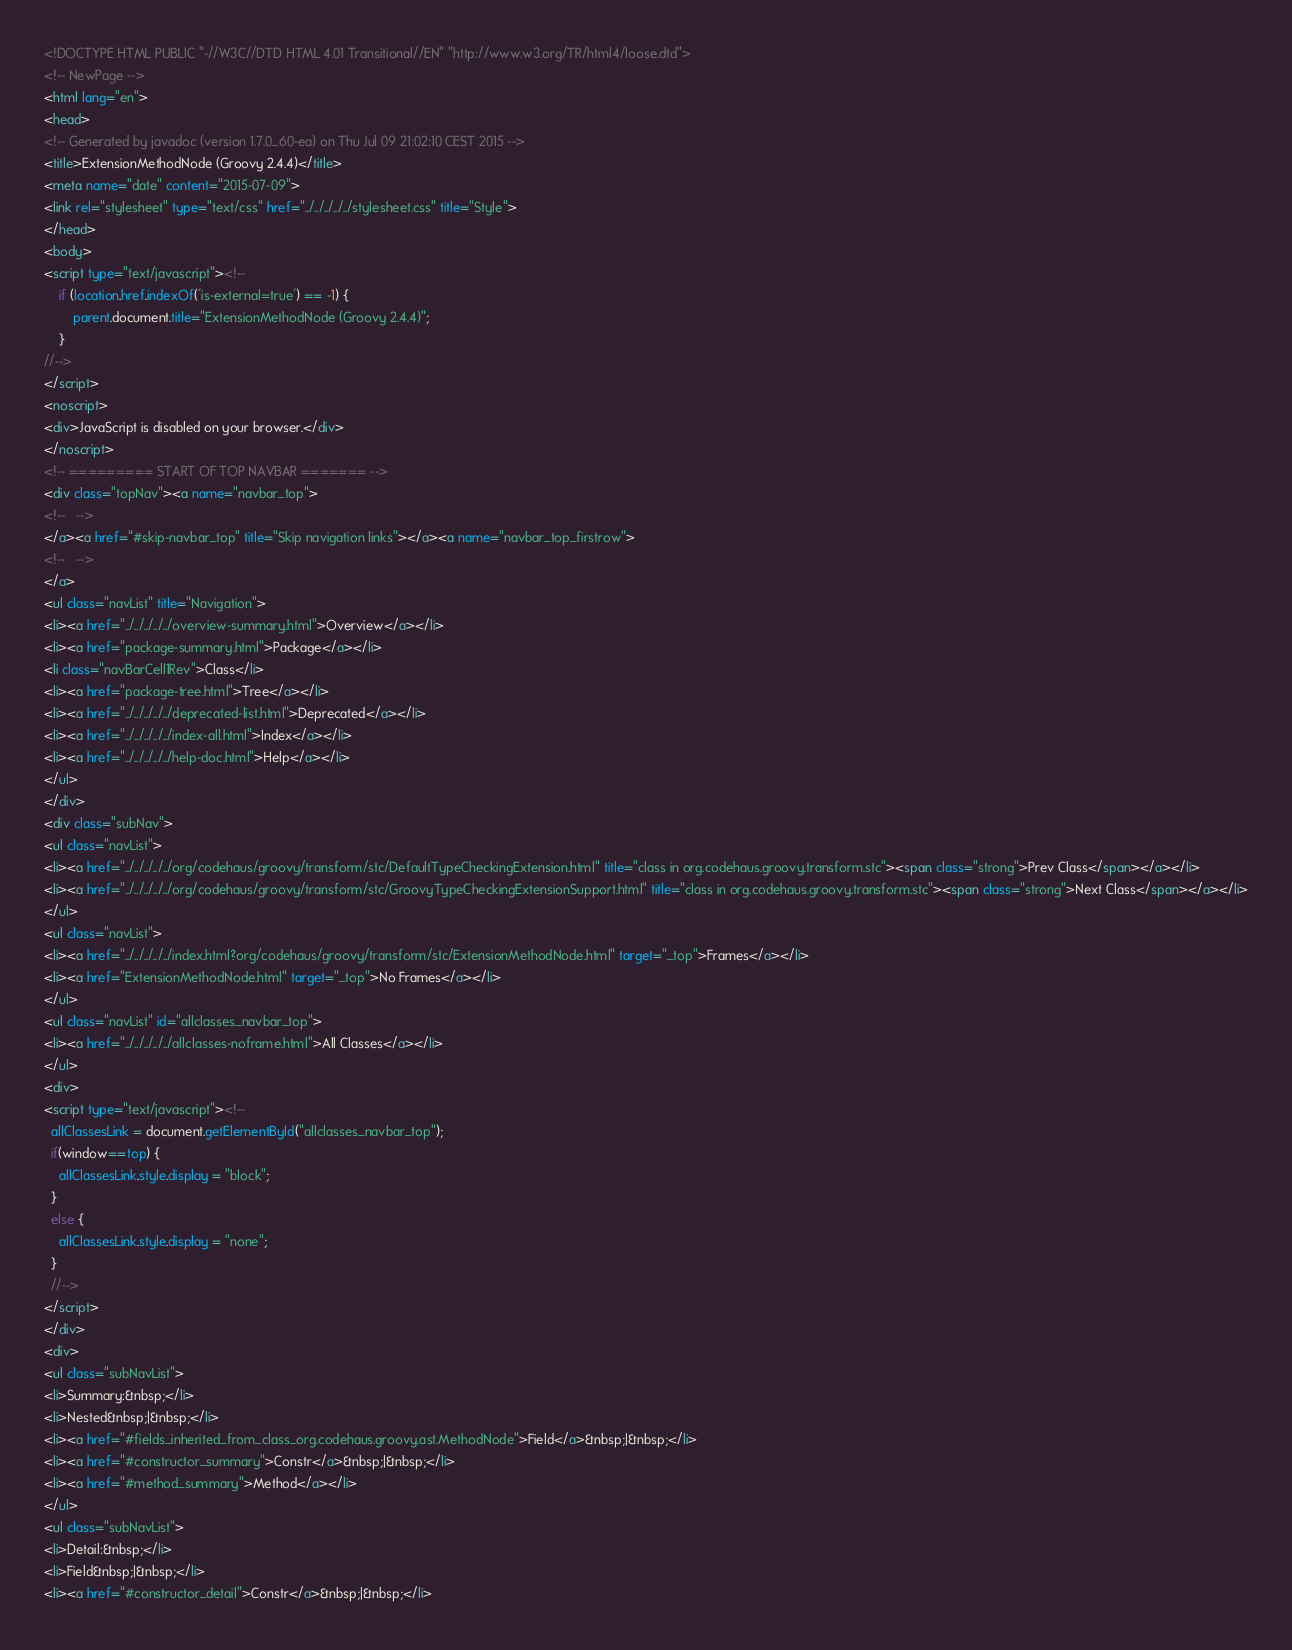<code> <loc_0><loc_0><loc_500><loc_500><_HTML_><!DOCTYPE HTML PUBLIC "-//W3C//DTD HTML 4.01 Transitional//EN" "http://www.w3.org/TR/html4/loose.dtd">
<!-- NewPage -->
<html lang="en">
<head>
<!-- Generated by javadoc (version 1.7.0_60-ea) on Thu Jul 09 21:02:10 CEST 2015 -->
<title>ExtensionMethodNode (Groovy 2.4.4)</title>
<meta name="date" content="2015-07-09">
<link rel="stylesheet" type="text/css" href="../../../../../stylesheet.css" title="Style">
</head>
<body>
<script type="text/javascript"><!--
    if (location.href.indexOf('is-external=true') == -1) {
        parent.document.title="ExtensionMethodNode (Groovy 2.4.4)";
    }
//-->
</script>
<noscript>
<div>JavaScript is disabled on your browser.</div>
</noscript>
<!-- ========= START OF TOP NAVBAR ======= -->
<div class="topNav"><a name="navbar_top">
<!--   -->
</a><a href="#skip-navbar_top" title="Skip navigation links"></a><a name="navbar_top_firstrow">
<!--   -->
</a>
<ul class="navList" title="Navigation">
<li><a href="../../../../../overview-summary.html">Overview</a></li>
<li><a href="package-summary.html">Package</a></li>
<li class="navBarCell1Rev">Class</li>
<li><a href="package-tree.html">Tree</a></li>
<li><a href="../../../../../deprecated-list.html">Deprecated</a></li>
<li><a href="../../../../../index-all.html">Index</a></li>
<li><a href="../../../../../help-doc.html">Help</a></li>
</ul>
</div>
<div class="subNav">
<ul class="navList">
<li><a href="../../../../../org/codehaus/groovy/transform/stc/DefaultTypeCheckingExtension.html" title="class in org.codehaus.groovy.transform.stc"><span class="strong">Prev Class</span></a></li>
<li><a href="../../../../../org/codehaus/groovy/transform/stc/GroovyTypeCheckingExtensionSupport.html" title="class in org.codehaus.groovy.transform.stc"><span class="strong">Next Class</span></a></li>
</ul>
<ul class="navList">
<li><a href="../../../../../index.html?org/codehaus/groovy/transform/stc/ExtensionMethodNode.html" target="_top">Frames</a></li>
<li><a href="ExtensionMethodNode.html" target="_top">No Frames</a></li>
</ul>
<ul class="navList" id="allclasses_navbar_top">
<li><a href="../../../../../allclasses-noframe.html">All Classes</a></li>
</ul>
<div>
<script type="text/javascript"><!--
  allClassesLink = document.getElementById("allclasses_navbar_top");
  if(window==top) {
    allClassesLink.style.display = "block";
  }
  else {
    allClassesLink.style.display = "none";
  }
  //-->
</script>
</div>
<div>
<ul class="subNavList">
<li>Summary:&nbsp;</li>
<li>Nested&nbsp;|&nbsp;</li>
<li><a href="#fields_inherited_from_class_org.codehaus.groovy.ast.MethodNode">Field</a>&nbsp;|&nbsp;</li>
<li><a href="#constructor_summary">Constr</a>&nbsp;|&nbsp;</li>
<li><a href="#method_summary">Method</a></li>
</ul>
<ul class="subNavList">
<li>Detail:&nbsp;</li>
<li>Field&nbsp;|&nbsp;</li>
<li><a href="#constructor_detail">Constr</a>&nbsp;|&nbsp;</li></code> 